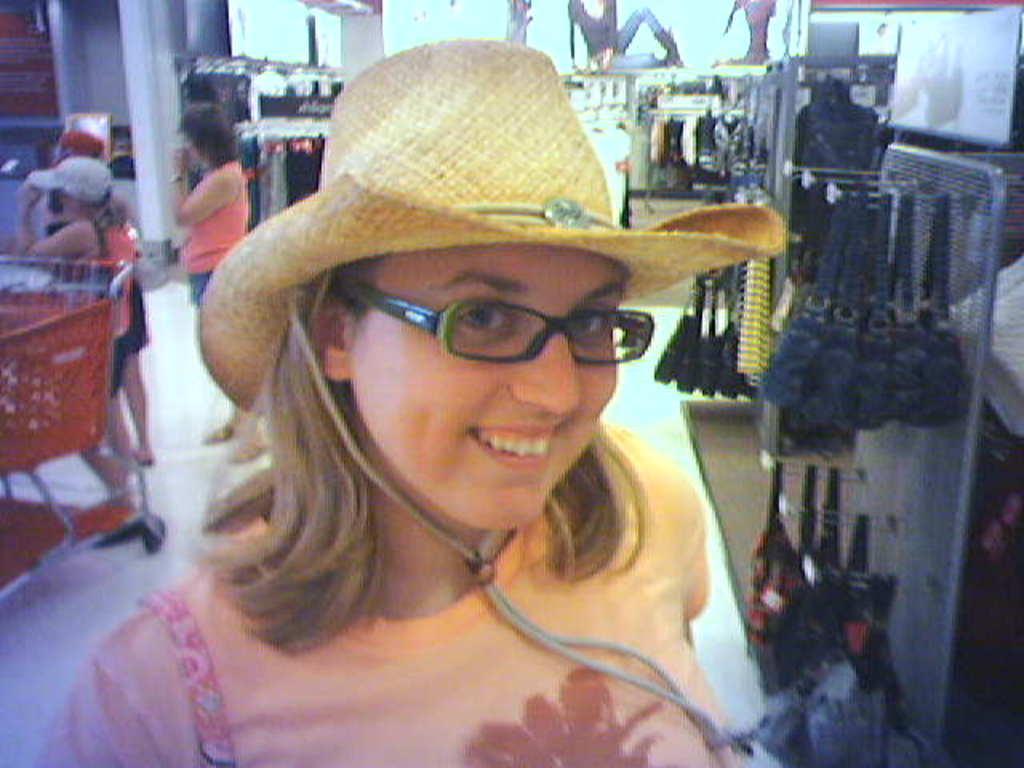Describe this image in one or two sentences. In the picture I can see a woman wearing hat and there are three persons and some other objects in the background. 